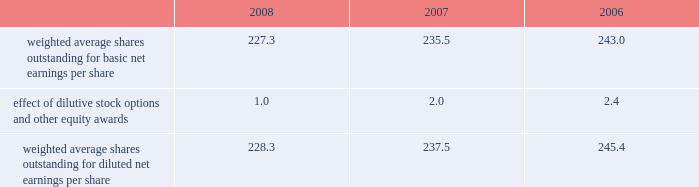Reasonably possible that such matters will be resolved in the next twelve months , but we do not anticipate that the resolution of these matters would result in any material impact on our results of operations or financial position .
Foreign jurisdictions have statutes of limitations generally ranging from 3 to 5 years .
Years still open to examination by foreign tax authorities in major jurisdictions include australia ( 2003 onward ) , canada ( 2002 onward ) , france ( 2006 onward ) , germany ( 2005 onward ) , italy ( 2005 onward ) , japan ( 2002 onward ) , puerto rico ( 2005 onward ) , singapore ( 2003 onward ) , switzerland ( 2006 onward ) and the united kingdom ( 2006 onward ) .
Our tax returns are currently under examination in various foreign jurisdictions .
The most significant foreign tax jurisdiction under examination is the united kingdom .
It is reasonably possible that such audits will be resolved in the next twelve months , but we do not anticipate that the resolution of these audits would result in any material impact on our results of operations or financial position .
13 .
Capital stock and earnings per share we are authorized to issue 250 million shares of preferred stock , none of which were issued or outstanding as of december 31 , 2008 .
The numerator for both basic and diluted earnings per share is net earnings available to common stockholders .
The denominator for basic earnings per share is the weighted average number of common shares outstanding during the period .
The denominator for diluted earnings per share is weighted average shares outstanding adjusted for the effect of dilutive stock options and other equity awards .
The following is a reconciliation of weighted average shares for the basic and diluted share computations for the years ending december 31 ( in millions ) : .
Weighted average shares outstanding for basic net earnings per share 227.3 235.5 243.0 effect of dilutive stock options and other equity awards 1.0 2.0 2.4 weighted average shares outstanding for diluted net earnings per share 228.3 237.5 245.4 for the year ended december 31 , 2008 , an average of 11.2 million options to purchase shares of common stock were not included in the computation of diluted earnings per share as the exercise prices of these options were greater than the average market price of the common stock .
For the years ended december 31 , 2007 and 2006 , an average of 3.1 million and 7.6 million options , respectively , were not included .
During 2008 , we repurchased approximately 10.8 million shares of our common stock at an average price of $ 68.72 per share for a total cash outlay of $ 737.0 million , including commissions .
In april 2008 , we announced that our board of directors authorized a $ 1.25 billion share repurchase program which expires december 31 , 2009 .
Approximately $ 1.13 billion remains authorized under this plan .
14 .
Segment data we design , develop , manufacture and market orthopaedic and dental reconstructive implants , spinal implants , trauma products and related surgical products which include surgical supplies and instruments designed to aid in orthopaedic surgical procedures and post-operation rehabilitation .
We also provide other healthcare-related services .
Revenue related to these services currently represents less than 1 percent of our total net sales .
We manage operations through three major geographic segments 2013 the americas , which is comprised principally of the united states and includes other north , central and south american markets ; europe , which is comprised principally of europe and includes the middle east and africa ; and asia pacific , which is comprised primarily of japan and includes other asian and pacific markets .
This structure is the basis for our reportable segment information discussed below .
Management evaluates operating segment performance based upon segment operating profit exclusive of operating expenses pertaining to global operations and corporate expenses , share-based compensation expense , settlement , certain claims , acquisition , integration and other expenses , inventory step-up , in-process research and development write-offs and intangible asset amortization expense .
Global operations include research , development engineering , medical education , brand management , corporate legal , finance , and human resource functions , and u.s .
And puerto rico-based manufacturing operations and logistics .
Intercompany transactions have been eliminated from segment operating profit .
Management reviews accounts receivable , inventory , property , plant and equipment , goodwill and intangible assets by reportable segment exclusive of u.s and puerto rico-based manufacturing operations and logistics and corporate assets .
Z i m m e r h o l d i n g s , i n c .
2 0 0 8 f o r m 1 0 - k a n n u a l r e p o r t notes to consolidated financial statements ( continued ) %%transmsg*** transmitting job : c48761 pcn : 058000000 ***%%pcmsg|58 |00011|yes|no|02/24/2009 19:25|0|0|page is valid , no graphics -- color : d| .
Percent change of average shares outstanding when taking dilution into consideration in 2008? 
Computations: ((228.3 / 227.3) - 1)
Answer: 0.0044. 